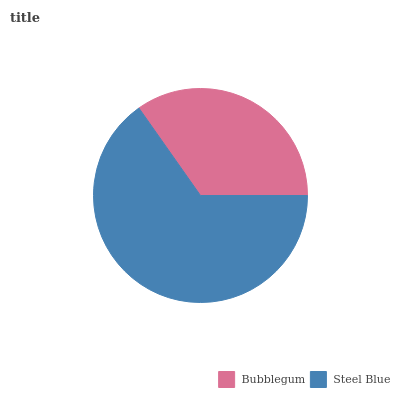Is Bubblegum the minimum?
Answer yes or no. Yes. Is Steel Blue the maximum?
Answer yes or no. Yes. Is Steel Blue the minimum?
Answer yes or no. No. Is Steel Blue greater than Bubblegum?
Answer yes or no. Yes. Is Bubblegum less than Steel Blue?
Answer yes or no. Yes. Is Bubblegum greater than Steel Blue?
Answer yes or no. No. Is Steel Blue less than Bubblegum?
Answer yes or no. No. Is Steel Blue the high median?
Answer yes or no. Yes. Is Bubblegum the low median?
Answer yes or no. Yes. Is Bubblegum the high median?
Answer yes or no. No. Is Steel Blue the low median?
Answer yes or no. No. 